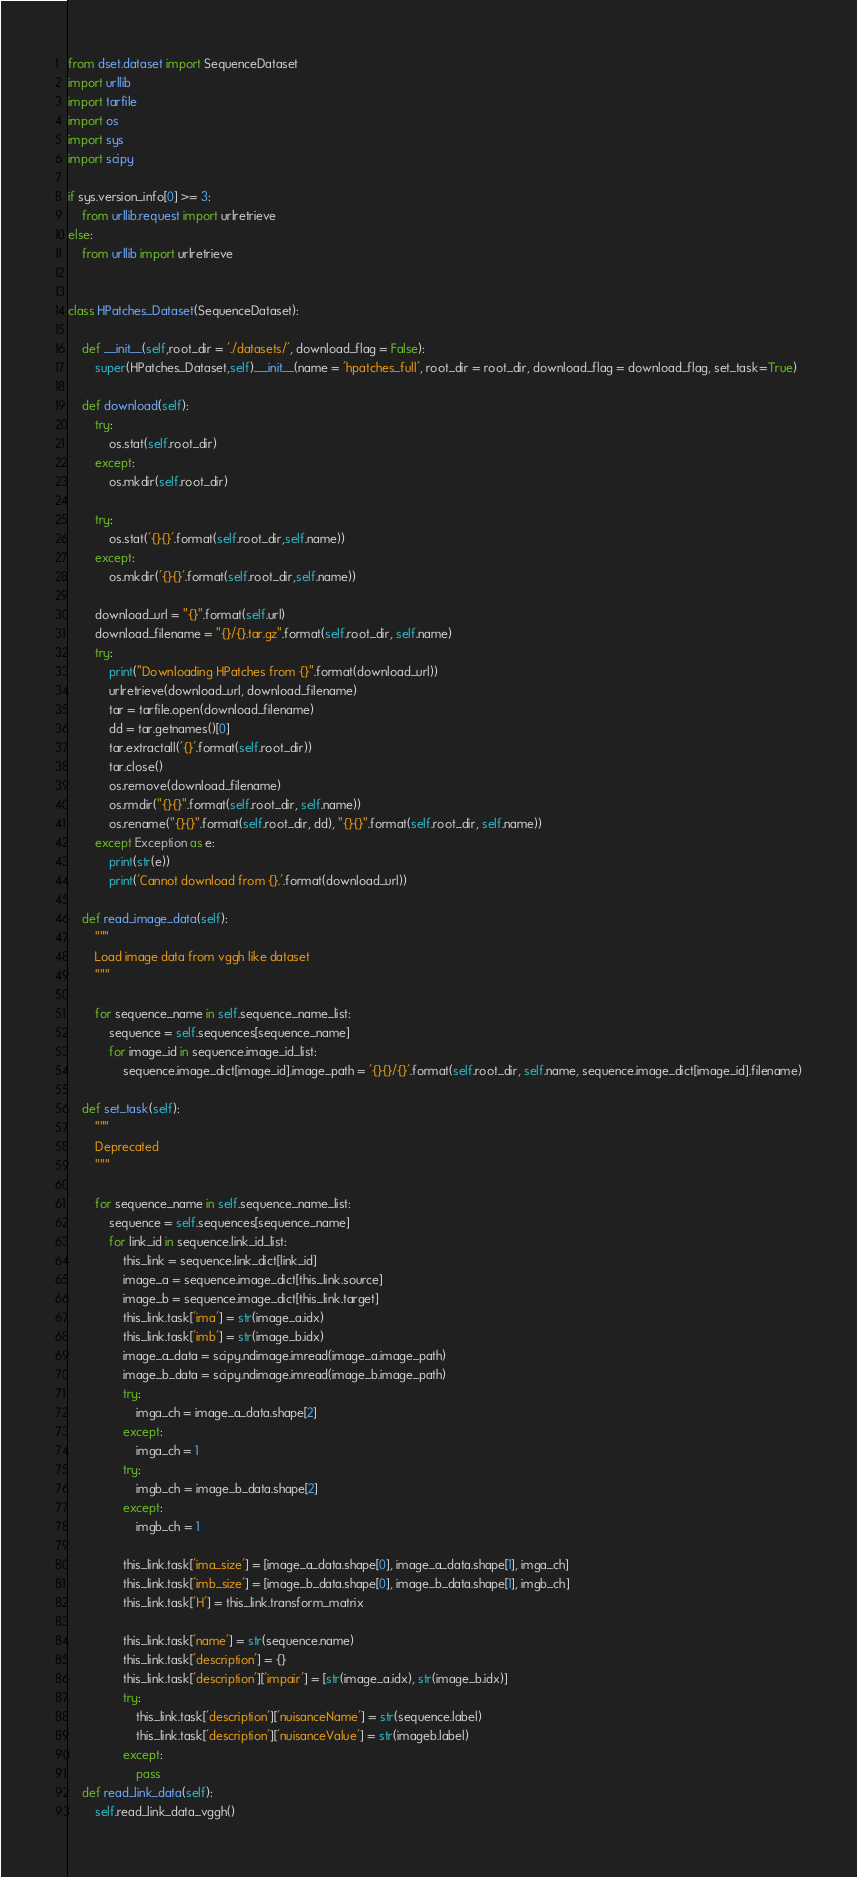Convert code to text. <code><loc_0><loc_0><loc_500><loc_500><_Python_>from dset.dataset import SequenceDataset
import urllib
import tarfile
import os
import sys
import scipy

if sys.version_info[0] >= 3:
    from urllib.request import urlretrieve
else:
    from urllib import urlretrieve


class HPatches_Dataset(SequenceDataset):

    def __init__(self,root_dir = './datasets/', download_flag = False):
        super(HPatches_Dataset,self).__init__(name = 'hpatches_full', root_dir = root_dir, download_flag = download_flag, set_task=True)

    def download(self):
        try:
            os.stat(self.root_dir)
        except:
            os.mkdir(self.root_dir)

        try:
            os.stat('{}{}'.format(self.root_dir,self.name))
        except:
            os.mkdir('{}{}'.format(self.root_dir,self.name))

        download_url = "{}".format(self.url)
        download_filename = "{}/{}.tar.gz".format(self.root_dir, self.name)
        try:
            print("Downloading HPatches from {}".format(download_url))
            urlretrieve(download_url, download_filename)
            tar = tarfile.open(download_filename)
            dd = tar.getnames()[0]
            tar.extractall('{}'.format(self.root_dir))
            tar.close()
            os.remove(download_filename)
            os.rmdir("{}{}".format(self.root_dir, self.name))
            os.rename("{}{}".format(self.root_dir, dd), "{}{}".format(self.root_dir, self.name))
        except Exception as e:
            print(str(e))
            print('Cannot download from {}.'.format(download_url))

    def read_image_data(self):
        """
        Load image data from vggh like dataset
        """

        for sequence_name in self.sequence_name_list:
            sequence = self.sequences[sequence_name]
            for image_id in sequence.image_id_list:
                sequence.image_dict[image_id].image_path = '{}{}/{}'.format(self.root_dir, self.name, sequence.image_dict[image_id].filename)

    def set_task(self):
        """
        Deprecated
        """

        for sequence_name in self.sequence_name_list:
            sequence = self.sequences[sequence_name]
            for link_id in sequence.link_id_list:
                this_link = sequence.link_dict[link_id]
                image_a = sequence.image_dict[this_link.source]
                image_b = sequence.image_dict[this_link.target]
                this_link.task['ima'] = str(image_a.idx)
                this_link.task['imb'] = str(image_b.idx)
                image_a_data = scipy.ndimage.imread(image_a.image_path)
                image_b_data = scipy.ndimage.imread(image_b.image_path)
                try:
                    imga_ch = image_a_data.shape[2]
                except:
                    imga_ch = 1
                try:
                    imgb_ch = image_b_data.shape[2]
                except:
                    imgb_ch = 1

                this_link.task['ima_size'] = [image_a_data.shape[0], image_a_data.shape[1], imga_ch]
                this_link.task['imb_size'] = [image_b_data.shape[0], image_b_data.shape[1], imgb_ch]
                this_link.task['H'] = this_link.transform_matrix

                this_link.task['name'] = str(sequence.name)
                this_link.task['description'] = {}
                this_link.task['description']['impair'] = [str(image_a.idx), str(image_b.idx)]
                try:
                    this_link.task['description']['nuisanceName'] = str(sequence.label)
                    this_link.task['description']['nuisanceValue'] = str(imageb.label)
                except:
                    pass
    def read_link_data(self):
        self.read_link_data_vggh()
</code> 